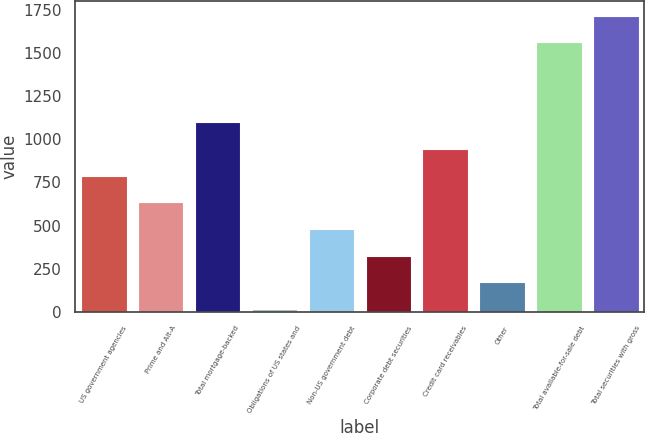Convert chart. <chart><loc_0><loc_0><loc_500><loc_500><bar_chart><fcel>US government agencies<fcel>Prime and Alt-A<fcel>Total mortgage-backed<fcel>Obligations of US states and<fcel>Non-US government debt<fcel>Corporate debt securities<fcel>Credit card receivables<fcel>Other<fcel>Total available-for-sale debt<fcel>Total securities with gross<nl><fcel>789<fcel>634.4<fcel>1098.2<fcel>16<fcel>479.8<fcel>325.2<fcel>943.6<fcel>170.6<fcel>1562<fcel>1716.6<nl></chart> 